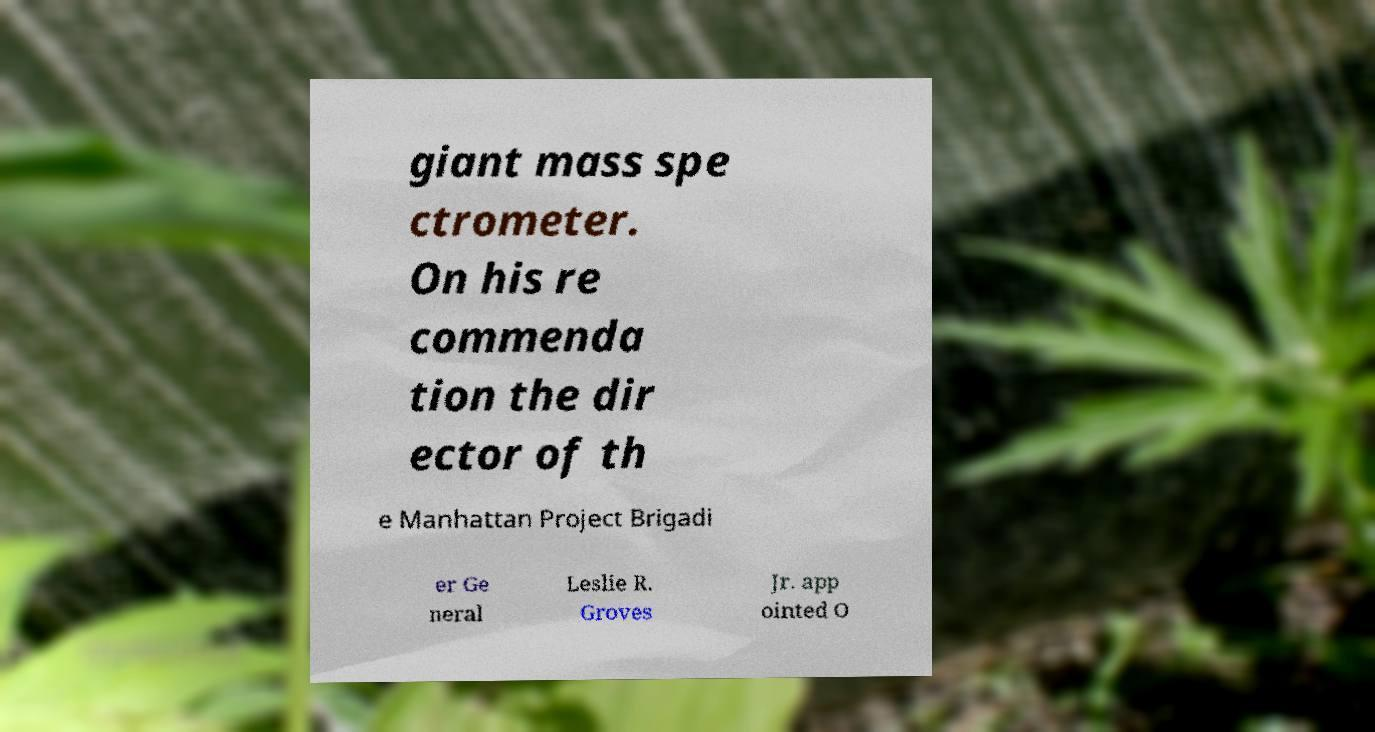Could you assist in decoding the text presented in this image and type it out clearly? giant mass spe ctrometer. On his re commenda tion the dir ector of th e Manhattan Project Brigadi er Ge neral Leslie R. Groves Jr. app ointed O 